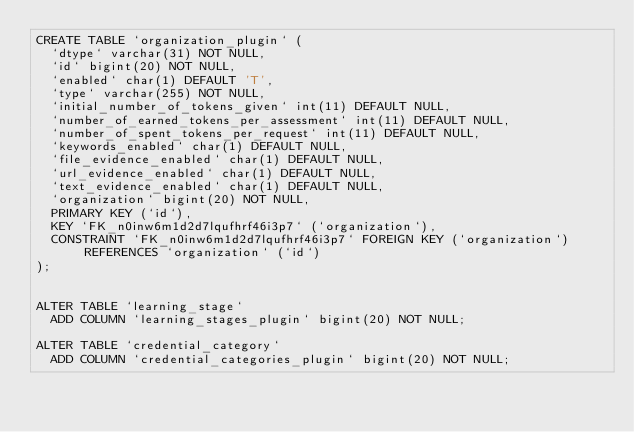<code> <loc_0><loc_0><loc_500><loc_500><_SQL_>CREATE TABLE `organization_plugin` (
  `dtype` varchar(31) NOT NULL,
  `id` bigint(20) NOT NULL,
  `enabled` char(1) DEFAULT 'T',
  `type` varchar(255) NOT NULL,
  `initial_number_of_tokens_given` int(11) DEFAULT NULL,
  `number_of_earned_tokens_per_assessment` int(11) DEFAULT NULL,
  `number_of_spent_tokens_per_request` int(11) DEFAULT NULL,
  `keywords_enabled` char(1) DEFAULT NULL,
  `file_evidence_enabled` char(1) DEFAULT NULL,
  `url_evidence_enabled` char(1) DEFAULT NULL,
  `text_evidence_enabled` char(1) DEFAULT NULL,
  `organization` bigint(20) NOT NULL,
  PRIMARY KEY (`id`),
  KEY `FK_n0inw6m1d2d7lqufhrf46i3p7` (`organization`),
  CONSTRAINT `FK_n0inw6m1d2d7lqufhrf46i3p7` FOREIGN KEY (`organization`) REFERENCES `organization` (`id`)
);


ALTER TABLE `learning_stage`
  ADD COLUMN `learning_stages_plugin` bigint(20) NOT NULL;

ALTER TABLE `credential_category`
  ADD COLUMN `credential_categories_plugin` bigint(20) NOT NULL;

</code> 